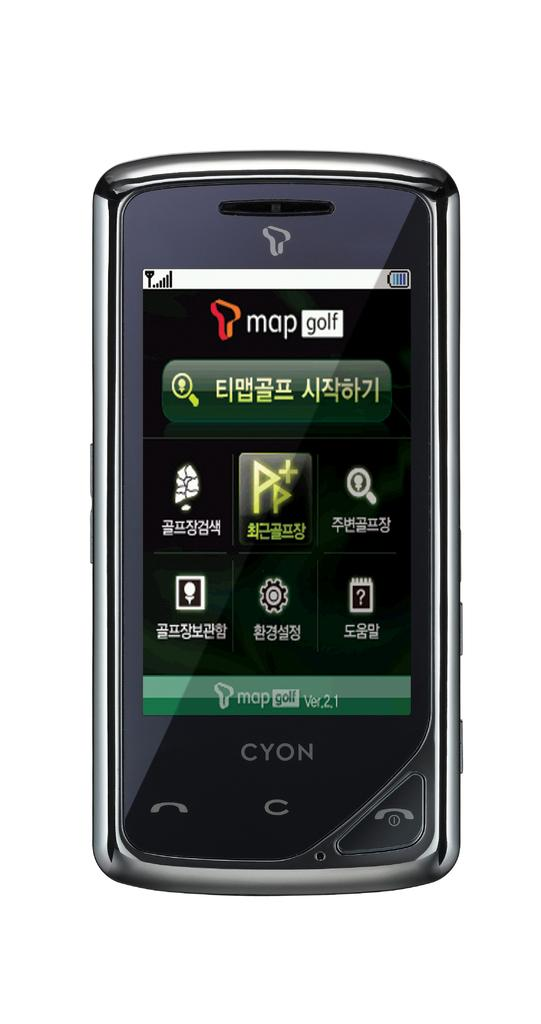<image>
Offer a succinct explanation of the picture presented. Cyon phone has many apps including 'map golf'. 